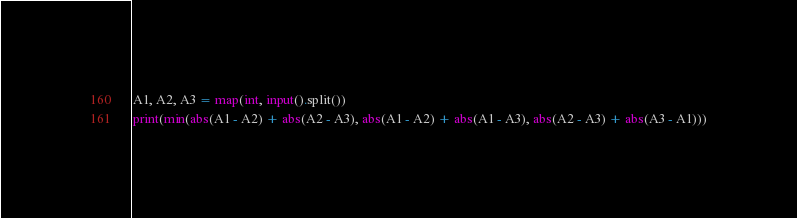<code> <loc_0><loc_0><loc_500><loc_500><_Python_>A1, A2, A3 = map(int, input().split())
print(min(abs(A1 - A2) + abs(A2 - A3), abs(A1 - A2) + abs(A1 - A3), abs(A2 - A3) + abs(A3 - A1)))</code> 